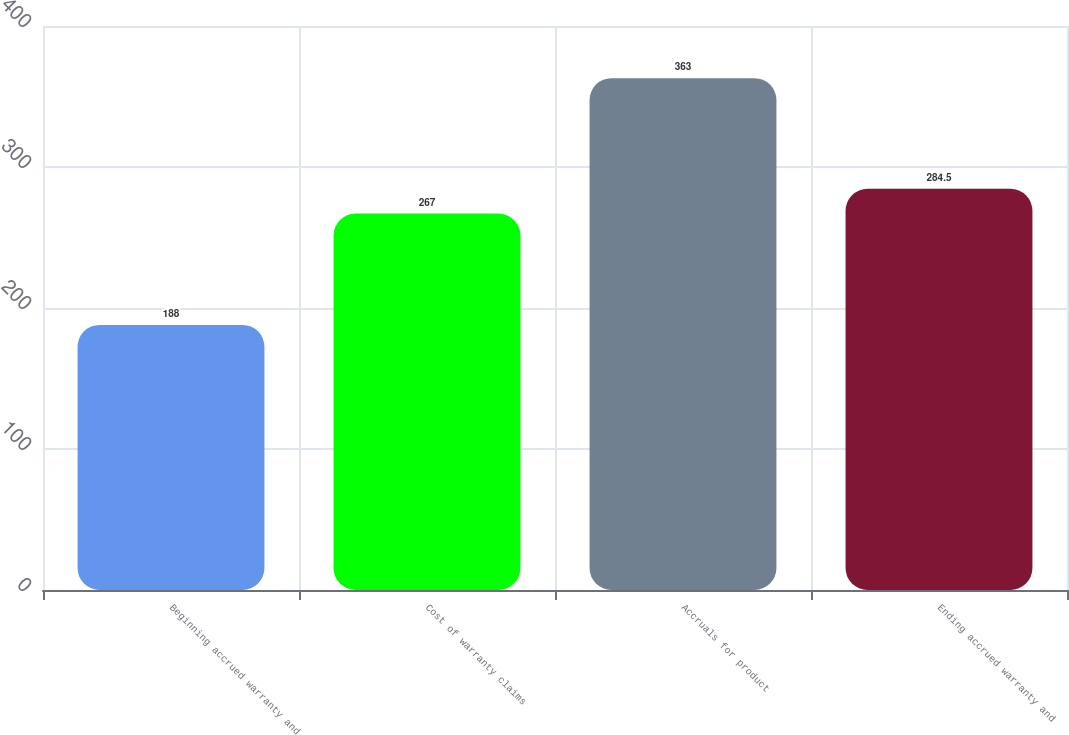Convert chart. <chart><loc_0><loc_0><loc_500><loc_500><bar_chart><fcel>Beginning accrued warranty and<fcel>Cost of warranty claims<fcel>Accruals for product<fcel>Ending accrued warranty and<nl><fcel>188<fcel>267<fcel>363<fcel>284.5<nl></chart> 